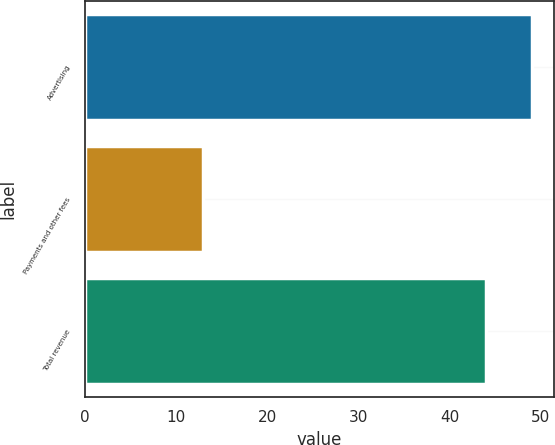Convert chart. <chart><loc_0><loc_0><loc_500><loc_500><bar_chart><fcel>Advertising<fcel>Payments and other fees<fcel>Total revenue<nl><fcel>49<fcel>13<fcel>44<nl></chart> 